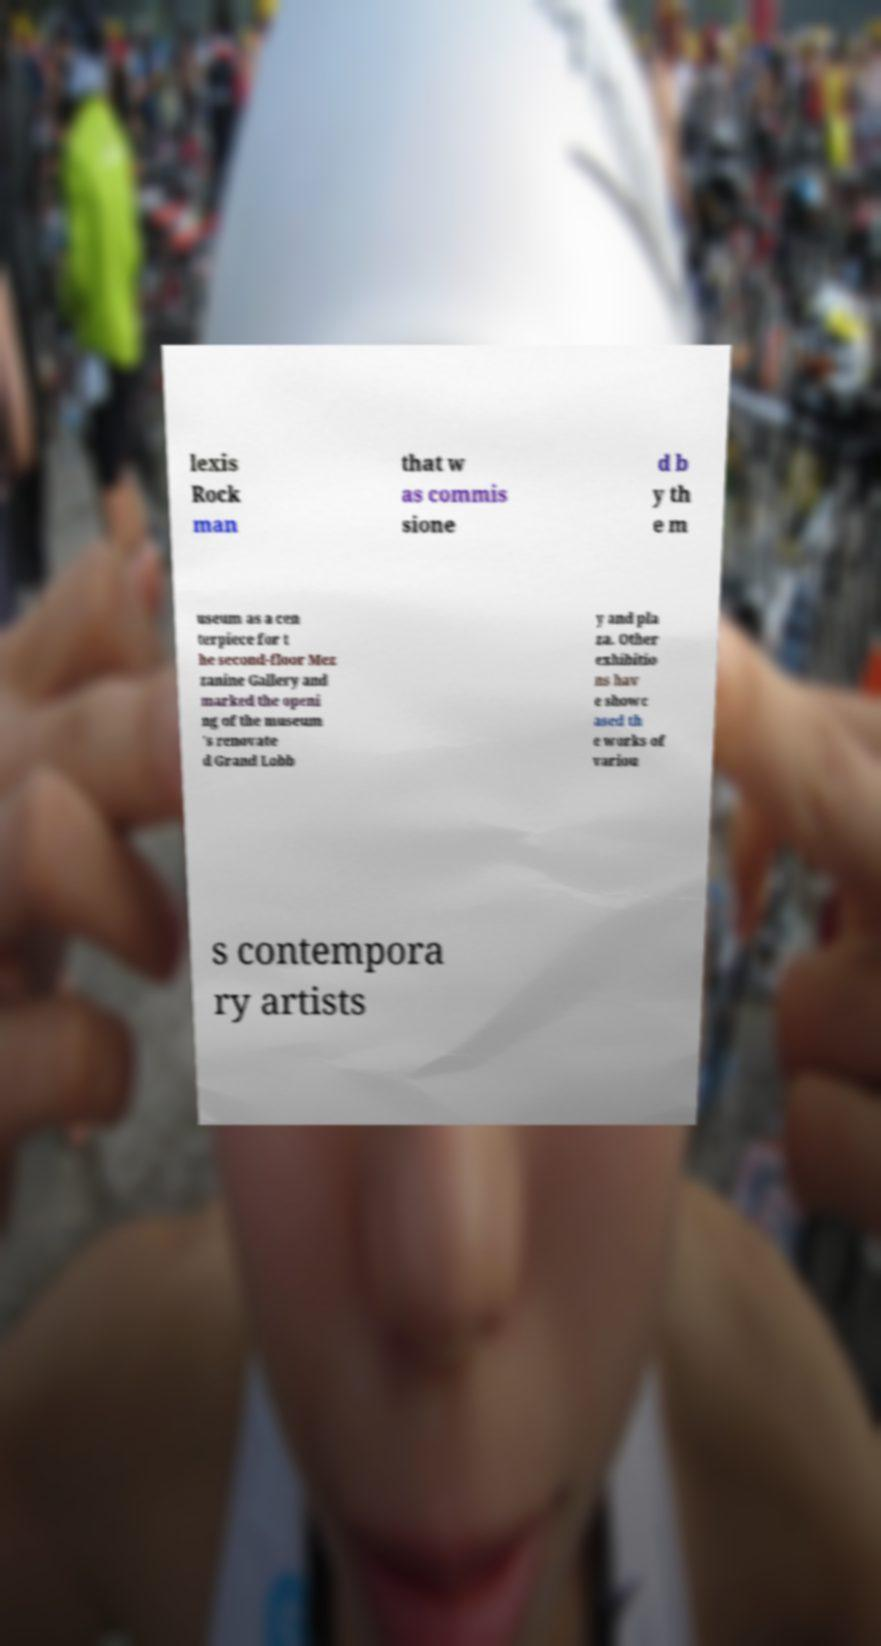Please read and relay the text visible in this image. What does it say? lexis Rock man that w as commis sione d b y th e m useum as a cen terpiece for t he second-floor Mez zanine Gallery and marked the openi ng of the museum 's renovate d Grand Lobb y and pla za. Other exhibitio ns hav e showc ased th e works of variou s contempora ry artists 